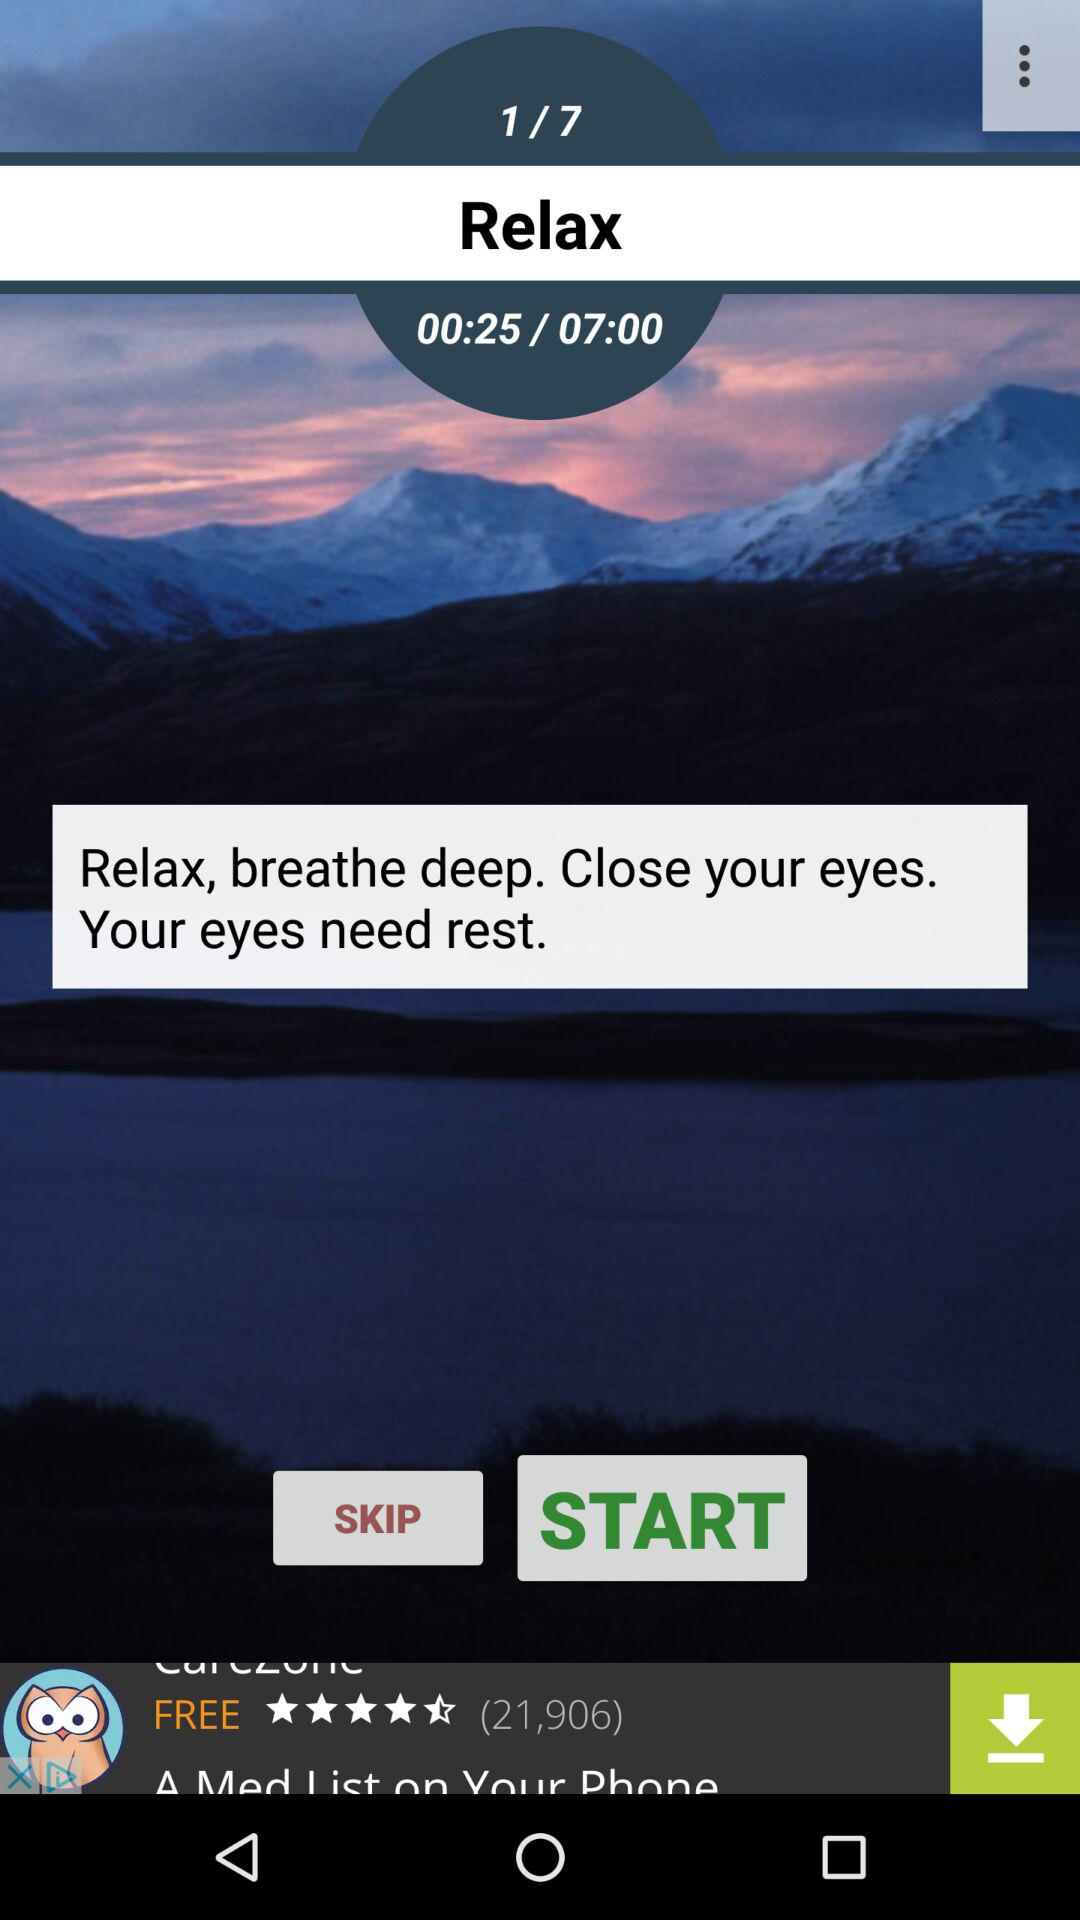What is the given time for relaxing? The given time for relaxing is 7 minutes. 